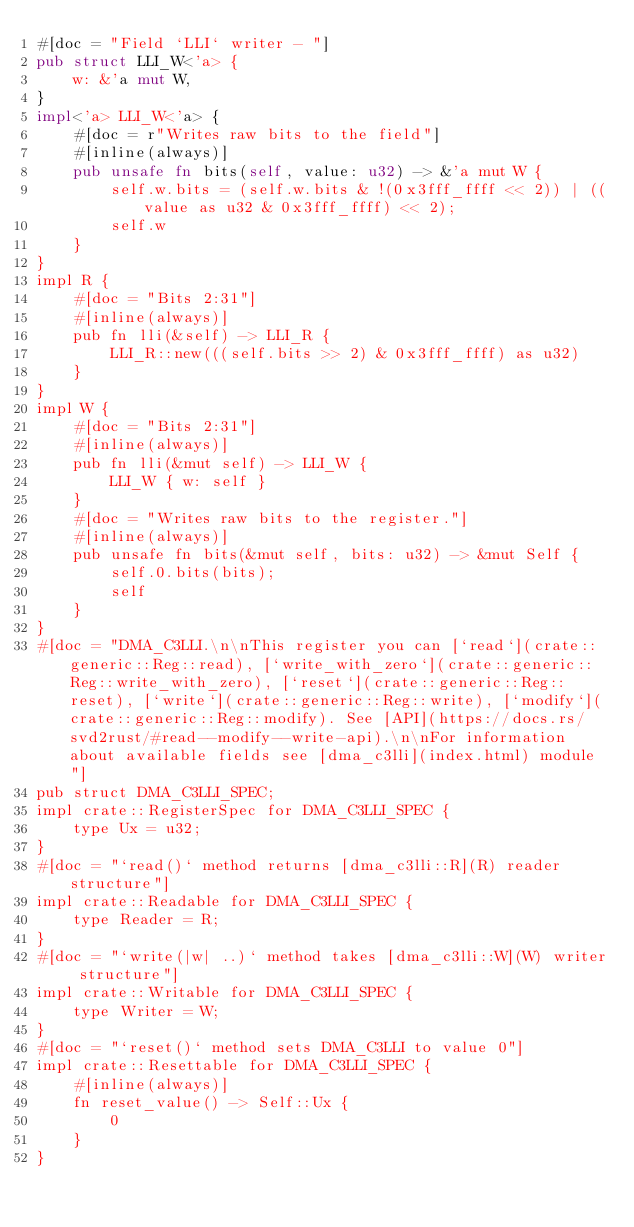<code> <loc_0><loc_0><loc_500><loc_500><_Rust_>#[doc = "Field `LLI` writer - "]
pub struct LLI_W<'a> {
    w: &'a mut W,
}
impl<'a> LLI_W<'a> {
    #[doc = r"Writes raw bits to the field"]
    #[inline(always)]
    pub unsafe fn bits(self, value: u32) -> &'a mut W {
        self.w.bits = (self.w.bits & !(0x3fff_ffff << 2)) | ((value as u32 & 0x3fff_ffff) << 2);
        self.w
    }
}
impl R {
    #[doc = "Bits 2:31"]
    #[inline(always)]
    pub fn lli(&self) -> LLI_R {
        LLI_R::new(((self.bits >> 2) & 0x3fff_ffff) as u32)
    }
}
impl W {
    #[doc = "Bits 2:31"]
    #[inline(always)]
    pub fn lli(&mut self) -> LLI_W {
        LLI_W { w: self }
    }
    #[doc = "Writes raw bits to the register."]
    #[inline(always)]
    pub unsafe fn bits(&mut self, bits: u32) -> &mut Self {
        self.0.bits(bits);
        self
    }
}
#[doc = "DMA_C3LLI.\n\nThis register you can [`read`](crate::generic::Reg::read), [`write_with_zero`](crate::generic::Reg::write_with_zero), [`reset`](crate::generic::Reg::reset), [`write`](crate::generic::Reg::write), [`modify`](crate::generic::Reg::modify). See [API](https://docs.rs/svd2rust/#read--modify--write-api).\n\nFor information about available fields see [dma_c3lli](index.html) module"]
pub struct DMA_C3LLI_SPEC;
impl crate::RegisterSpec for DMA_C3LLI_SPEC {
    type Ux = u32;
}
#[doc = "`read()` method returns [dma_c3lli::R](R) reader structure"]
impl crate::Readable for DMA_C3LLI_SPEC {
    type Reader = R;
}
#[doc = "`write(|w| ..)` method takes [dma_c3lli::W](W) writer structure"]
impl crate::Writable for DMA_C3LLI_SPEC {
    type Writer = W;
}
#[doc = "`reset()` method sets DMA_C3LLI to value 0"]
impl crate::Resettable for DMA_C3LLI_SPEC {
    #[inline(always)]
    fn reset_value() -> Self::Ux {
        0
    }
}
</code> 